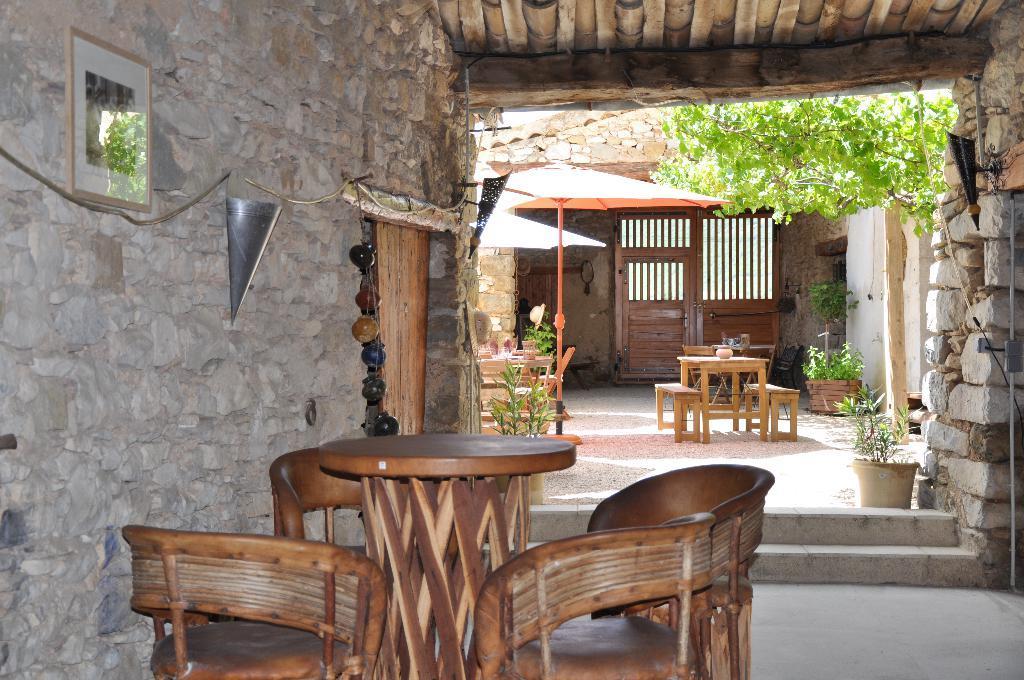In one or two sentences, can you explain what this image depicts? In this image i can see a wooden table and few chairs around it. To the left of the image i can see the wall, few decorating , a door and a photo frame attached to the wall. In the back ground i can see a tree, a tent , few tables and chairs few plants and the door. 